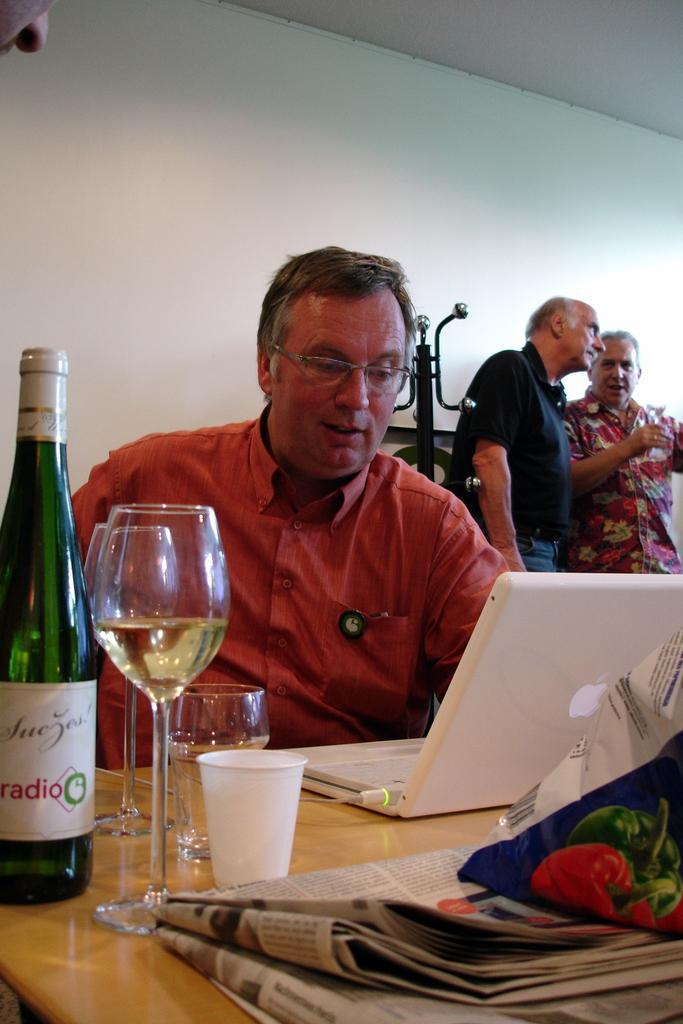Please provide a concise description of this image. There are three persons. The two persons are standing on the right side. One person is wearing a spectacle. On the left side of the person is sitting on a chair. He is wearing a spectacle. There is a table. There is a laptop, bottle,glass,cup on a table. We can see in the background wall. 